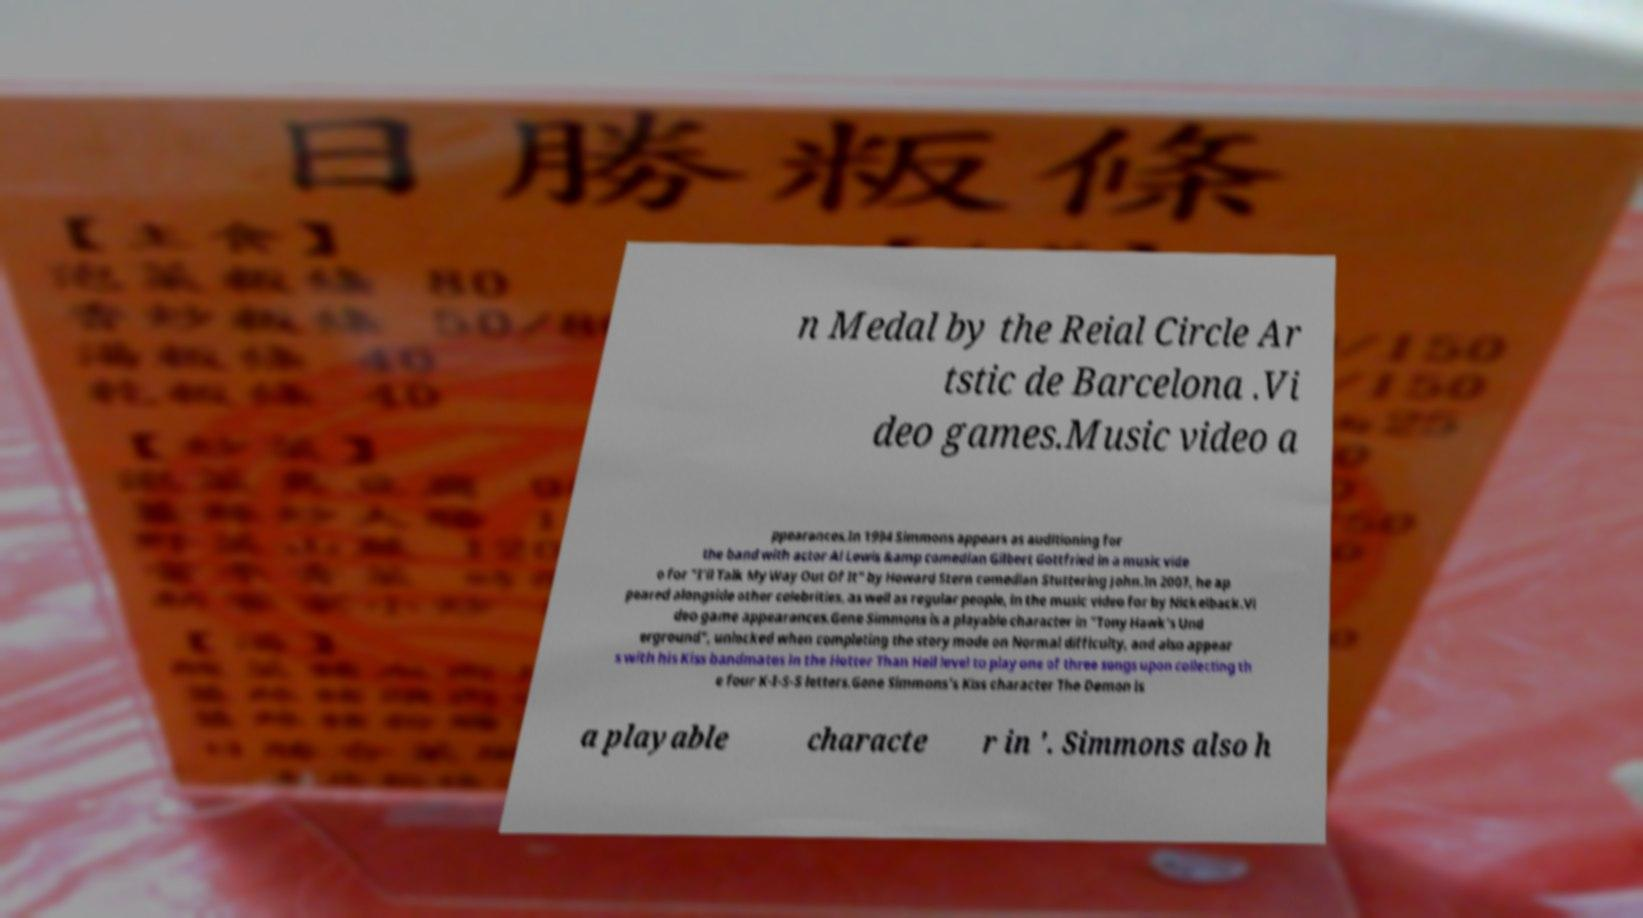Can you accurately transcribe the text from the provided image for me? n Medal by the Reial Circle Ar tstic de Barcelona .Vi deo games.Music video a ppearances.In 1994 Simmons appears as auditioning for the band with actor Al Lewis &amp comedian Gilbert Gottfried in a music vide o for "I'll Talk My Way Out Of It" by Howard Stern comedian Stuttering John.In 2007, he ap peared alongside other celebrities, as well as regular people, in the music video for by Nickelback.Vi deo game appearances.Gene Simmons is a playable character in "Tony Hawk's Und erground", unlocked when completing the story mode on Normal difficulty, and also appear s with his Kiss bandmates in the Hotter Than Hell level to play one of three songs upon collecting th e four K-I-S-S letters.Gene Simmons's Kiss character The Demon is a playable characte r in '. Simmons also h 